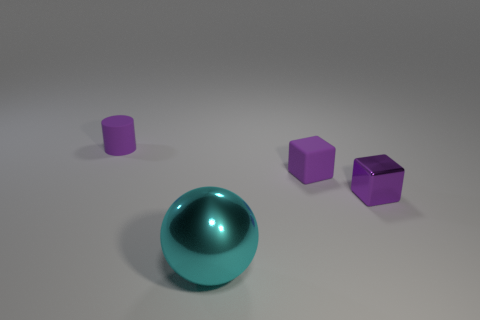Add 2 cyan shiny cylinders. How many objects exist? 6 Subtract all cylinders. How many objects are left? 3 Add 3 gray rubber spheres. How many gray rubber spheres exist? 3 Subtract 0 red cylinders. How many objects are left? 4 Subtract all big purple blocks. Subtract all purple objects. How many objects are left? 1 Add 3 large cyan shiny balls. How many large cyan shiny balls are left? 4 